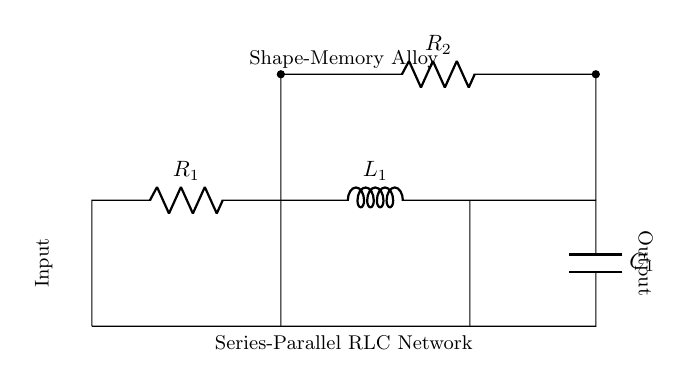What types of components are in the circuit? The circuit contains resistors, an inductor, and a capacitor. These components are indicated in the diagram with their respective symbols.
Answer: resistors, inductor, capacitor How many resistors are in the circuit? The diagram shows two resistors labeled as R1 and R2. The count can be obtained by visually identifying the resistor symbols in the circuit.
Answer: 2 What is the function of the inductor in this circuit? The role of the inductor in an RLC circuit is to store energy in the magnetic field when current flows through it, affecting the circuit's impedance and phase. This is crucial for simulating dynamics in a shape-memory alloy.
Answer: Store energy What is the arrangement of the capacitors and resistors? In the diagram, one resistor \( R_2 \) is in a parallel arrangement with \( C_1 \), while \( R_1 \) and \( L_1 \) are in series with each other before connecting to the capacitor. This structure affects how voltage is distributed across the network.
Answer: Series-parallel What is the significance of using a series-parallel RLC network? A series-parallel RLC network allows for complex impedance characteristics, enabling better modeling of phase transitions in materials like shape-memory alloys through tailored resonance and reactance behaviors. This results in enhanced simulations of their properties.
Answer: Complex impedance What is the role of the shape-memory alloy in this circuit? The shape-memory alloy serves as an active element that enables the circuit to mimic phase transitions, thereby facilitating the study of electrical properties associated with these transitions. This adds a real-world physical behavior to the modeled circuit.
Answer: Active element 